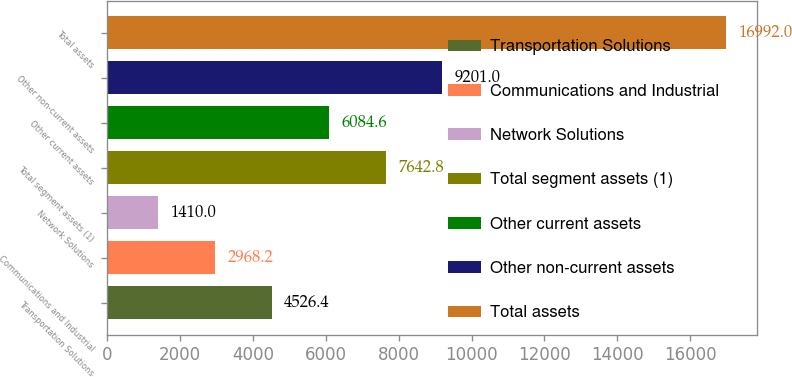Convert chart to OTSL. <chart><loc_0><loc_0><loc_500><loc_500><bar_chart><fcel>Transportation Solutions<fcel>Communications and Industrial<fcel>Network Solutions<fcel>Total segment assets (1)<fcel>Other current assets<fcel>Other non-current assets<fcel>Total assets<nl><fcel>4526.4<fcel>2968.2<fcel>1410<fcel>7642.8<fcel>6084.6<fcel>9201<fcel>16992<nl></chart> 